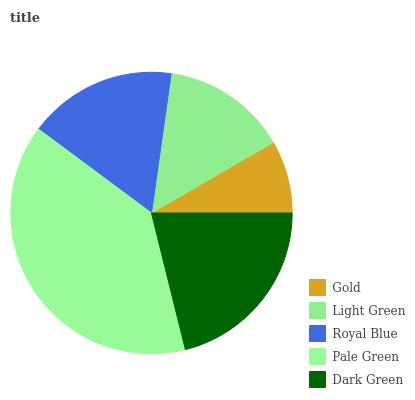Is Gold the minimum?
Answer yes or no. Yes. Is Pale Green the maximum?
Answer yes or no. Yes. Is Light Green the minimum?
Answer yes or no. No. Is Light Green the maximum?
Answer yes or no. No. Is Light Green greater than Gold?
Answer yes or no. Yes. Is Gold less than Light Green?
Answer yes or no. Yes. Is Gold greater than Light Green?
Answer yes or no. No. Is Light Green less than Gold?
Answer yes or no. No. Is Royal Blue the high median?
Answer yes or no. Yes. Is Royal Blue the low median?
Answer yes or no. Yes. Is Pale Green the high median?
Answer yes or no. No. Is Light Green the low median?
Answer yes or no. No. 